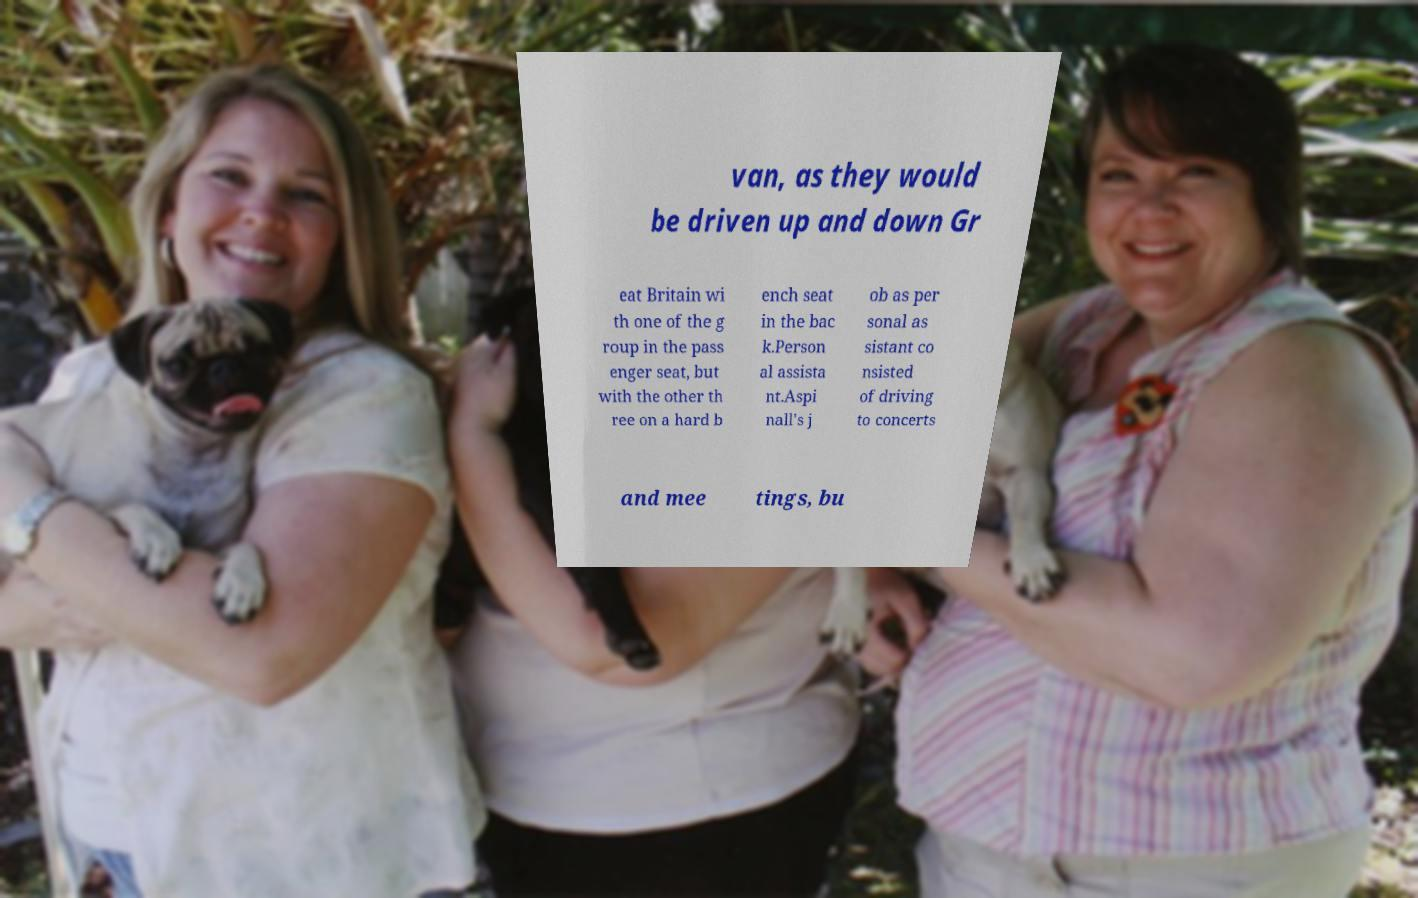Please read and relay the text visible in this image. What does it say? van, as they would be driven up and down Gr eat Britain wi th one of the g roup in the pass enger seat, but with the other th ree on a hard b ench seat in the bac k.Person al assista nt.Aspi nall's j ob as per sonal as sistant co nsisted of driving to concerts and mee tings, bu 